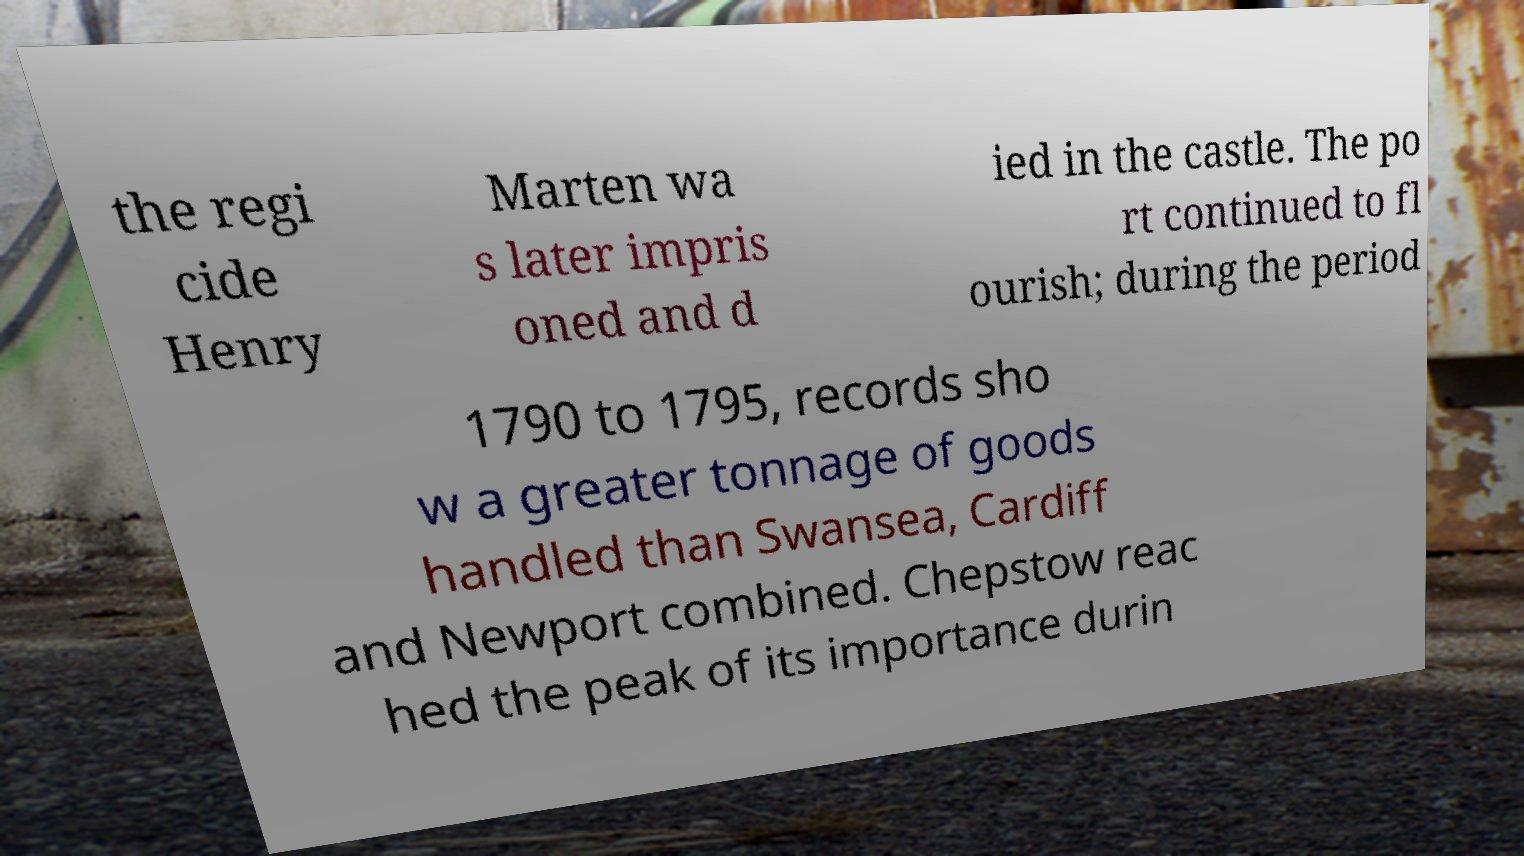What messages or text are displayed in this image? I need them in a readable, typed format. the regi cide Henry Marten wa s later impris oned and d ied in the castle. The po rt continued to fl ourish; during the period 1790 to 1795, records sho w a greater tonnage of goods handled than Swansea, Cardiff and Newport combined. Chepstow reac hed the peak of its importance durin 